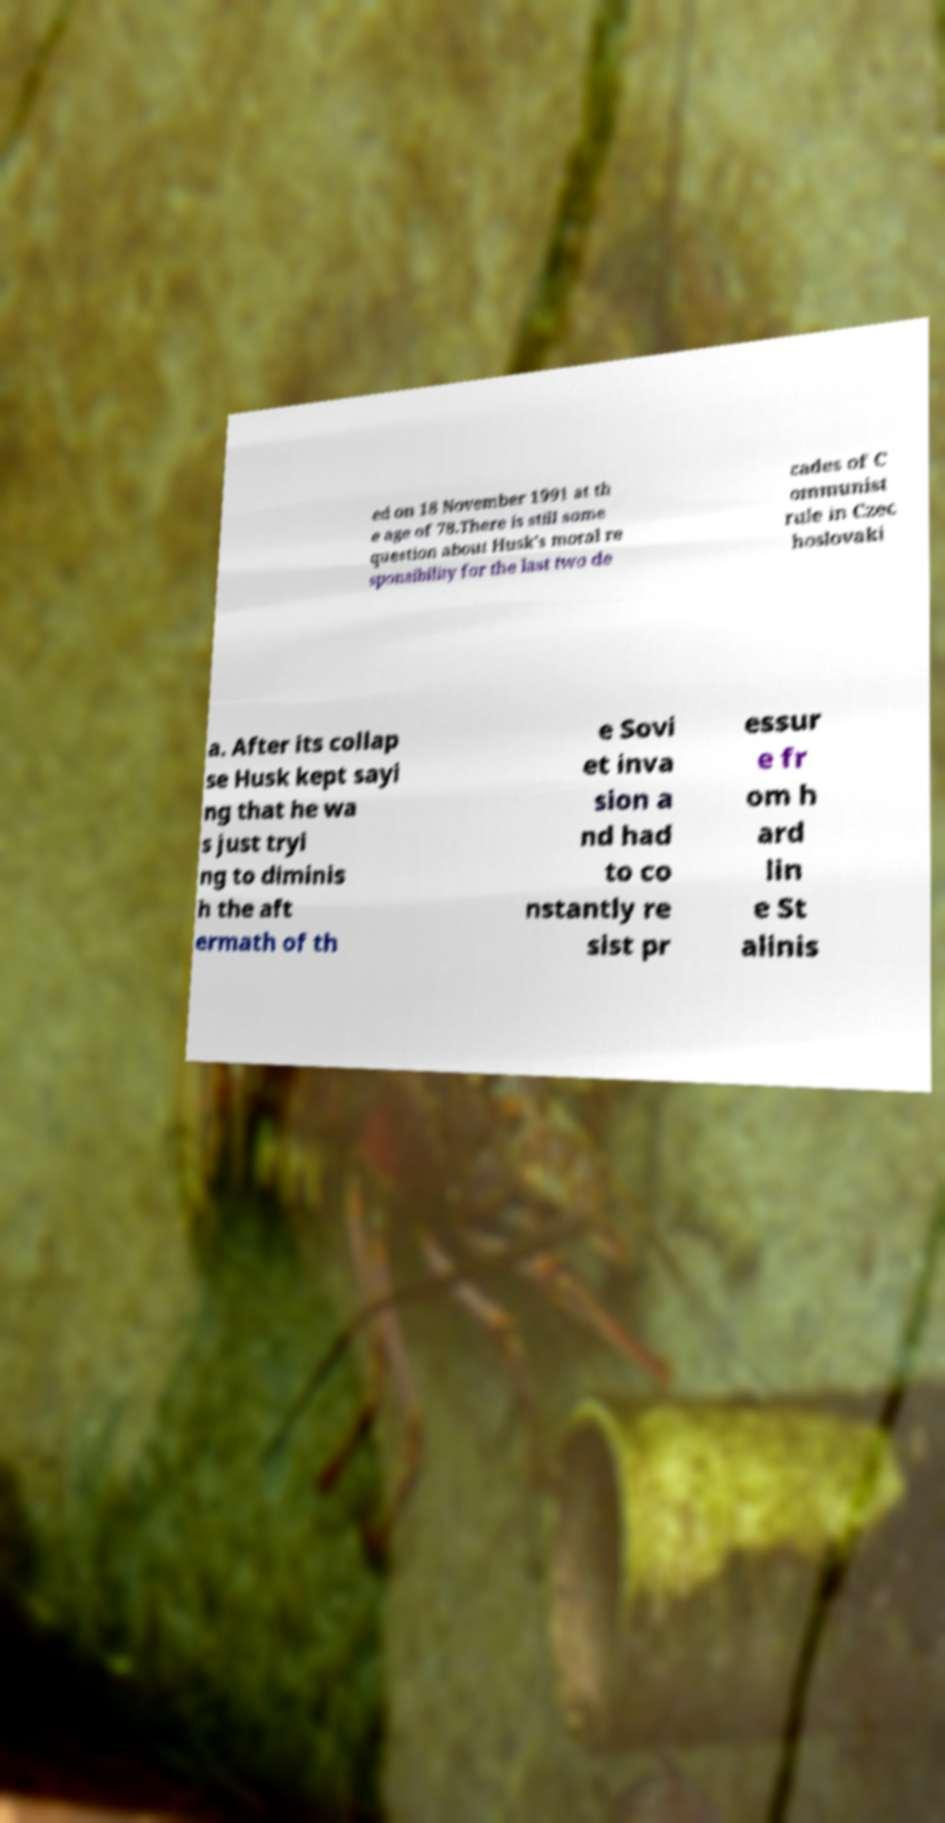I need the written content from this picture converted into text. Can you do that? ed on 18 November 1991 at th e age of 78.There is still some question about Husk's moral re sponsibility for the last two de cades of C ommunist rule in Czec hoslovaki a. After its collap se Husk kept sayi ng that he wa s just tryi ng to diminis h the aft ermath of th e Sovi et inva sion a nd had to co nstantly re sist pr essur e fr om h ard lin e St alinis 